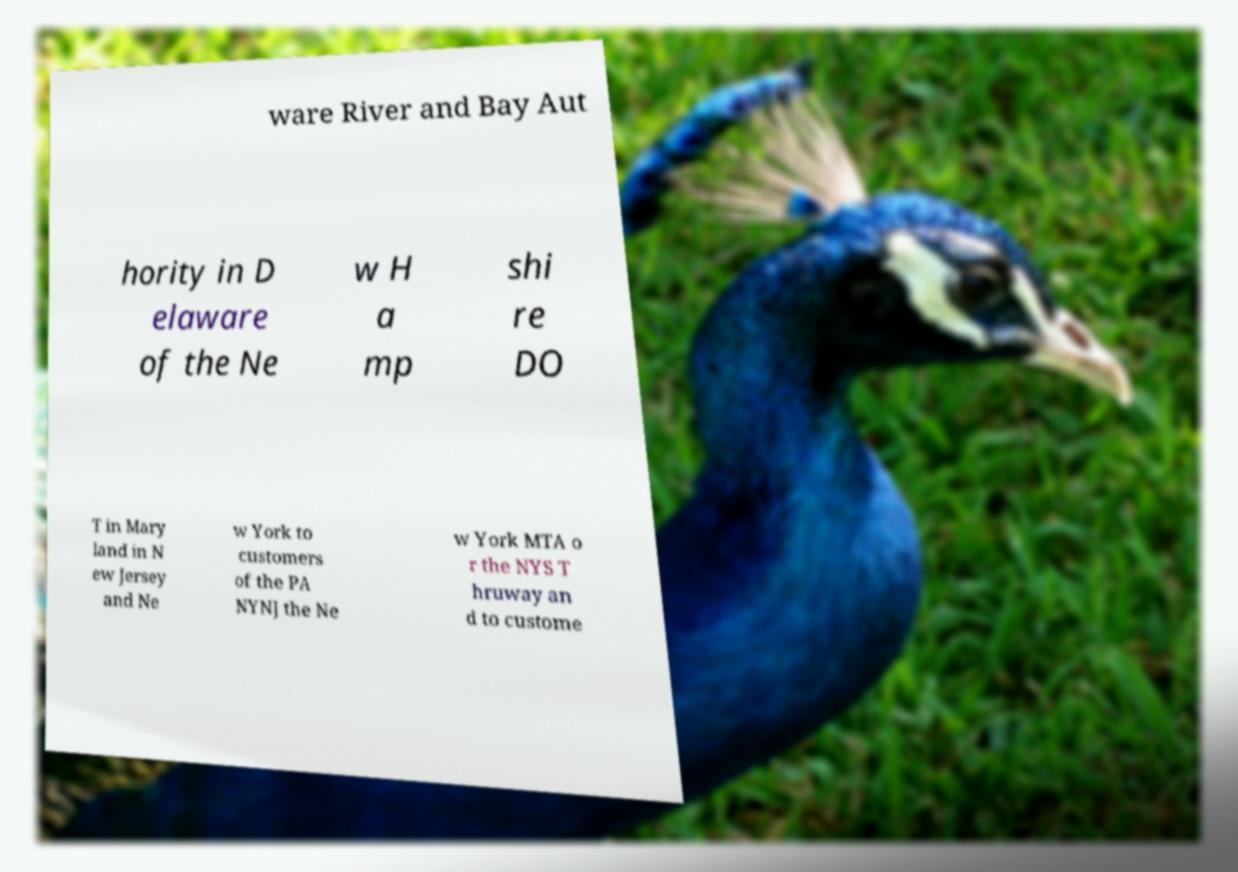Could you assist in decoding the text presented in this image and type it out clearly? ware River and Bay Aut hority in D elaware of the Ne w H a mp shi re DO T in Mary land in N ew Jersey and Ne w York to customers of the PA NYNJ the Ne w York MTA o r the NYS T hruway an d to custome 